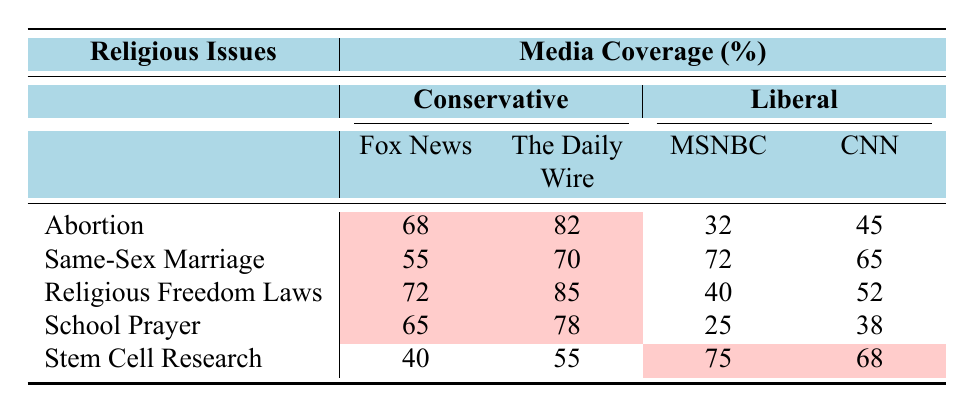What is the highest percentage of media coverage on abortion from conservative media? The highest percentage for conservative media coverage on abortion can be found by comparing the values for Fox News (68), The Daily Wire (82), Breitbart (75), and The Blaze (79). The Daily Wire has the highest at 82%.
Answer: 82% What is the lowest percentage of media coverage on school prayer from liberal media? The values for liberal media coverage on school prayer are MSNBC (25), CNN (38), HuffPost (20), and Vox (30). The lowest percentage is from HuffPost at 20%.
Answer: 20% What is the average percentage of conservative media coverage on same-sex marriage? To find the average, sum the percentages of conservative media for same-sex marriage: Fox News (55), The Daily Wire (70), Breitbart (63), and The Blaze (68). The total is 55 + 70 + 63 + 68 = 256. There are 4 outlets, so the average is 256 / 4 = 64%.
Answer: 64% Is there more liberal media coverage on stem cell research than on school prayer? The liberal media coverage for stem cell research is 75% (MSNBC), 68% (CNN), 82% (HuffPost), and 78% (Vox). For school prayer, it is 25% (MSNBC), 38% (CNN), 20% (HuffPost), and 30% (Vox). The average for stem cell research, which is higher than that for school prayer.
Answer: Yes What is the difference in conservative media coverage percentages between religious freedom laws and abortion? First, find the conservative media coverage for religious freedom laws: Fox News (72), The Daily Wire (85), Breitbart (78), and The Blaze (80). The average is (72 + 85 + 78 + 80) / 4 = 78.75%. For abortion, the average is (68 + 82 + 75 + 79) / 4 = 76%. The difference is 78.75 - 76 = 2.75%.
Answer: 2.75% Which religious issue has the highest overall media coverage percentage from liberal media? Examine the average coverage percentages for liberal media across all topics: Abortion 45%, Same-Sex Marriage 72%, Religious Freedom Laws 45%, School Prayer 28%, and Stem Cell Research 78%. The highest is for Same-Sex Marriage at 72%.
Answer: Same-Sex Marriage What is the total media coverage percentage for Fox News across all issues? To find the total for Fox News, add the percentages from each issue: Abortion (68%), Same-Sex Marriage (55%), Religious Freedom Laws (72%), School Prayer (65%), and Stem Cell Research (40%). Total = 68 + 55 + 72 + 65 + 40 = 300%.
Answer: 300% Is the percentage of liberal media coverage on same-sex marriage higher than that of conservative media coverage? It is necessary to compare liberal media coverage (72% for MSNBC, 65% for CNN, 80% for HuffPost, 75% for Vox) with conservative media coverage (55% for Fox News, 70% for The Daily Wire, 63% for Breitbart, 68% for The Blaze). The average for liberal media is higher than the conservative's average coverage on this issue.
Answer: Yes How much higher is the percentage of The Daily Wire's coverage on religious freedom laws compared to CNN's coverage on the same issue? The Daily Wire's percentage for religious freedom laws is 85%, while CNN's is 52%. The difference is calculated by subtracting: 85 - 52 = 33%.
Answer: 33% What percent of Fox News coverage on stem cell research is lower than their coverage on same-sex marriage? Compare the percentages: stem cell research is 40% and same-sex marriage is 55%. Find the difference: 55 - 40 = 15%.
Answer: 15% 